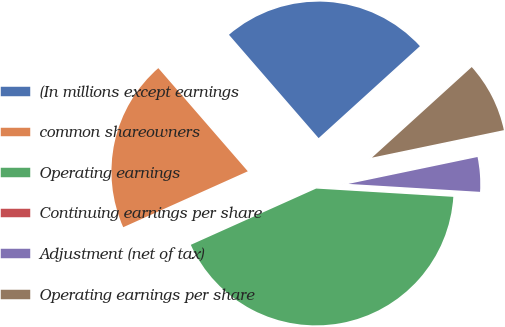<chart> <loc_0><loc_0><loc_500><loc_500><pie_chart><fcel>(In millions except earnings<fcel>common shareowners<fcel>Operating earnings<fcel>Continuing earnings per share<fcel>Adjustment (net of tax)<fcel>Operating earnings per share<nl><fcel>24.64%<fcel>20.34%<fcel>42.32%<fcel>0.0%<fcel>4.23%<fcel>8.46%<nl></chart> 